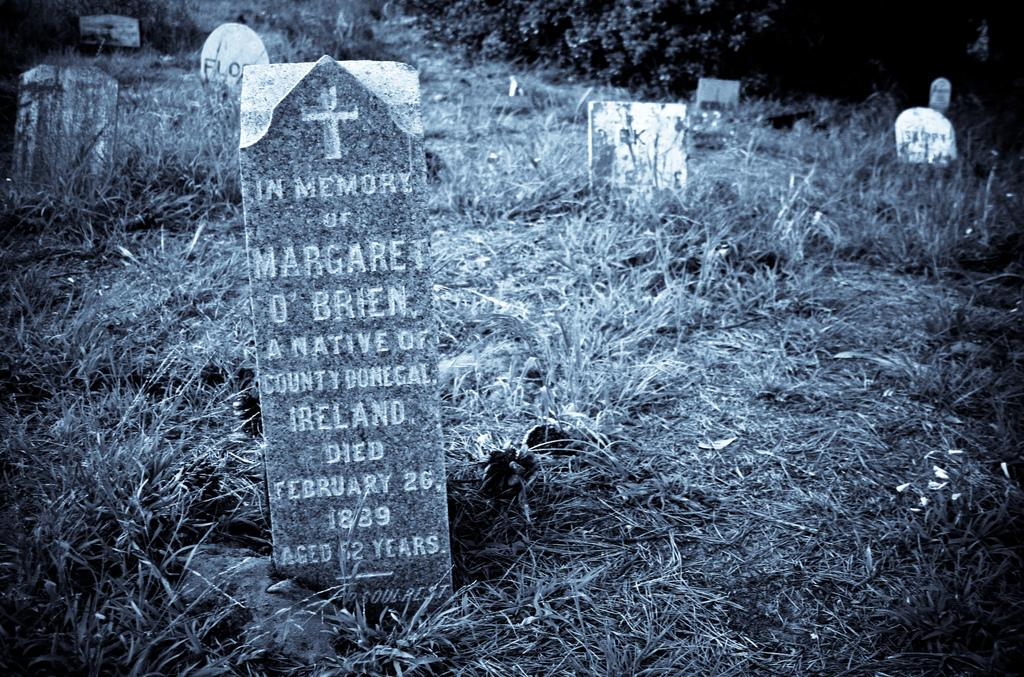What is the color scheme of the image? The image is black and white. What type of vegetation is present in the image? There are plants in the image. What are the other objects in the image besides the plants? There are memorial stones and grass in the image. What can be found on the memorial stones? Something is written on the memorial stones. How does the pump function in the image? There is no pump present in the image. What time of day is depicted in the image? The image does not provide information about the time of day, as it is in black and white. 